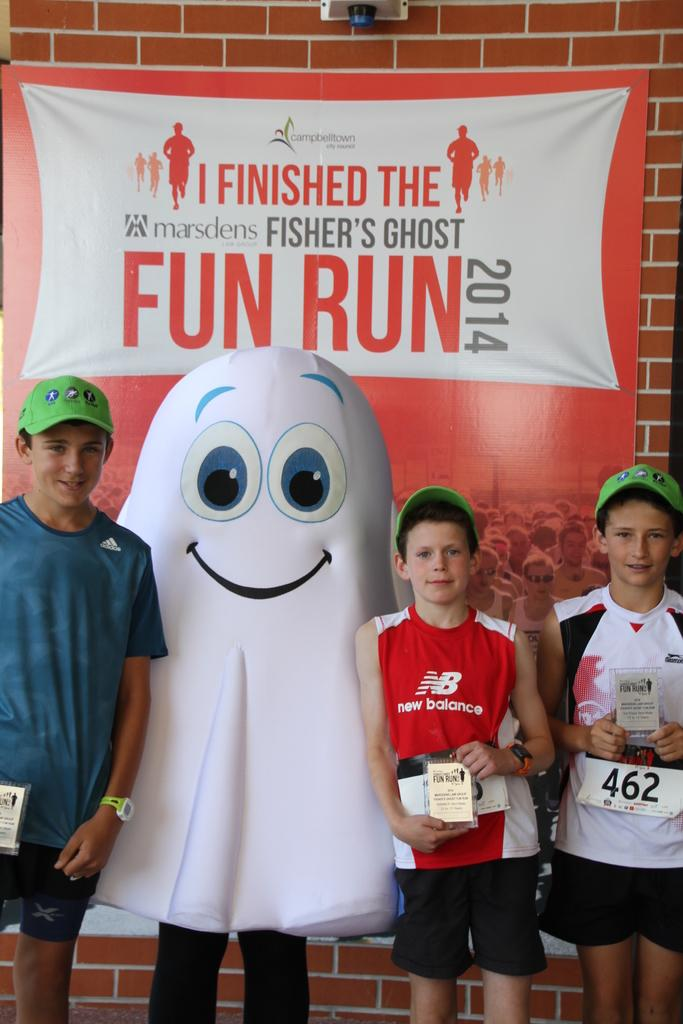How many kids are present in the image? There are three kids in the image. What are the kids wearing on their heads? The kids are wearing hats. What type of visual content is featured in the image? There is a cartoon in the image. What can be seen in the background of the image? There is a poster in the background of the image. Can you tell me how many feathers are on the kids' hats in the image? There is no information about feathers on the kids' hats in the image. What fact can be learned about the cartoon from the image? The image does not provide any specific facts about the cartoon; it only shows that there is a cartoon present. 